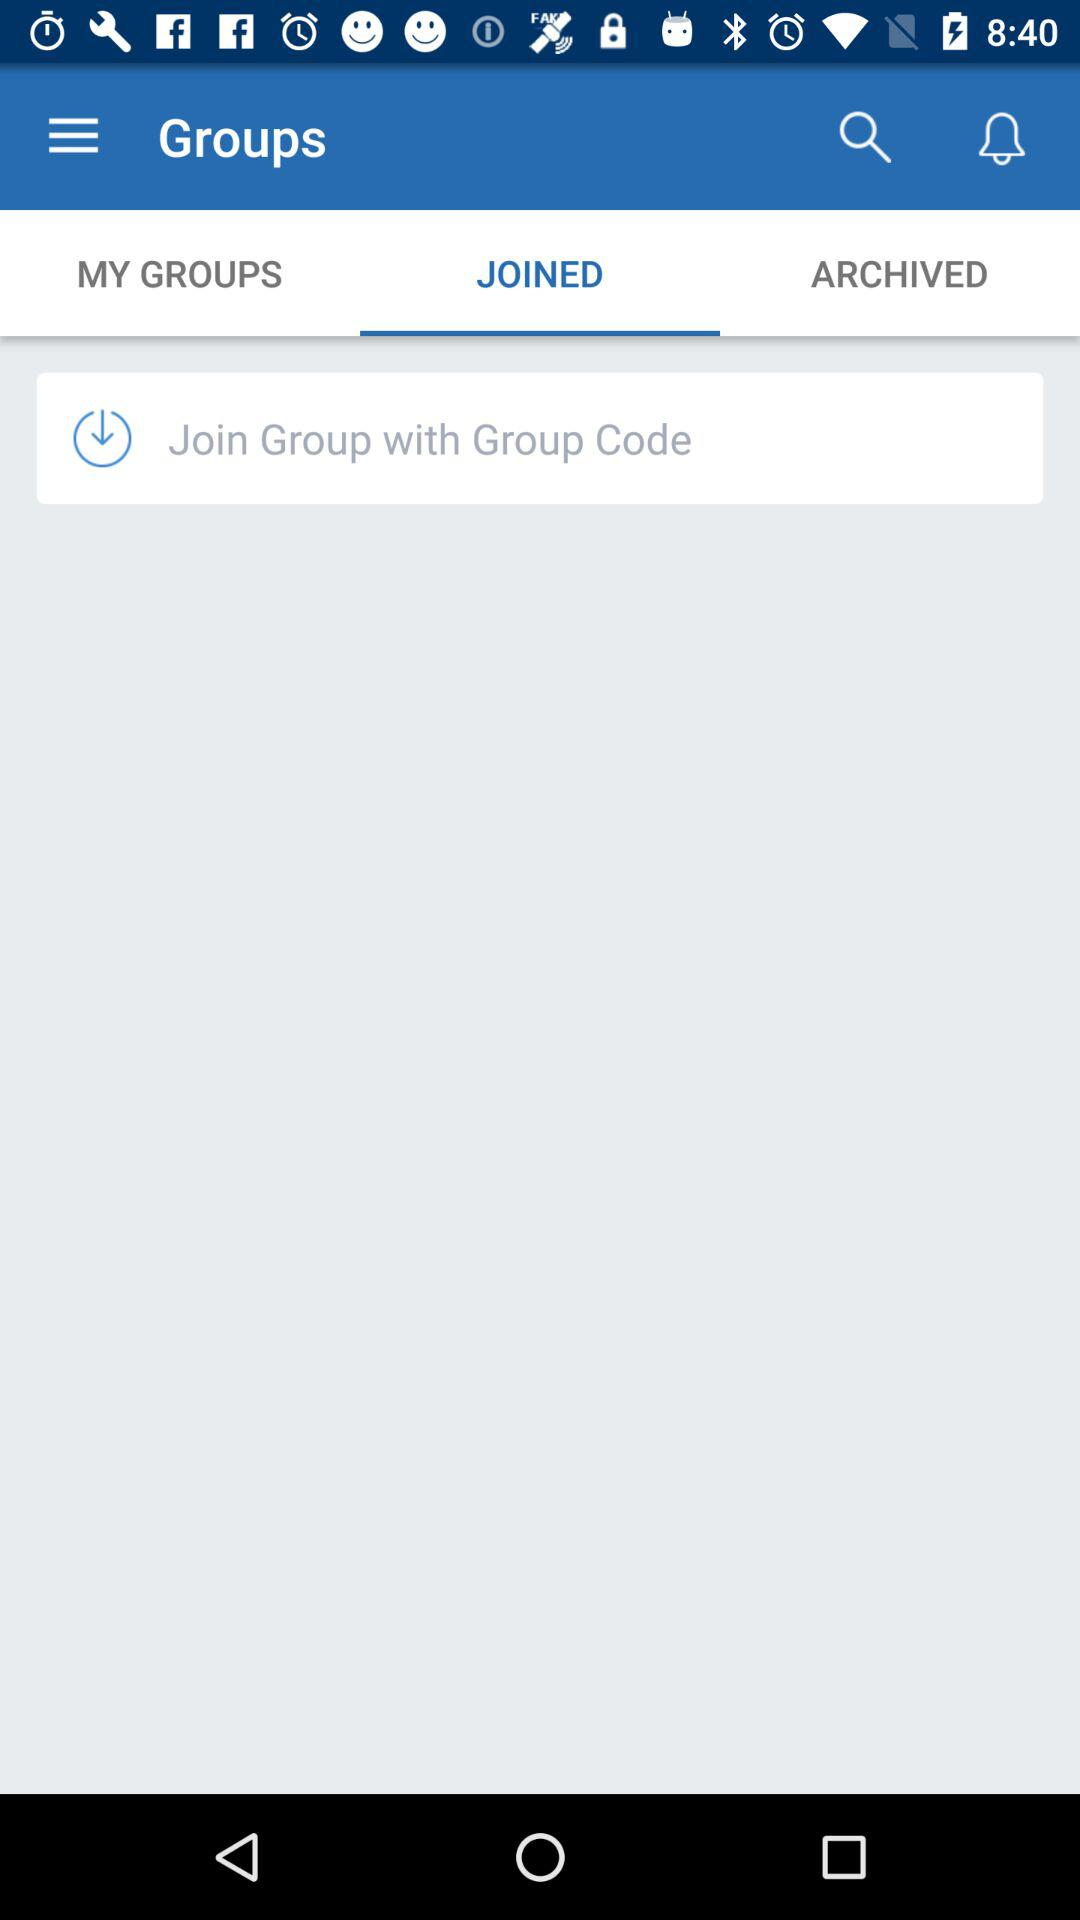Which tab am I using? You are using the "JOINED" tab. 